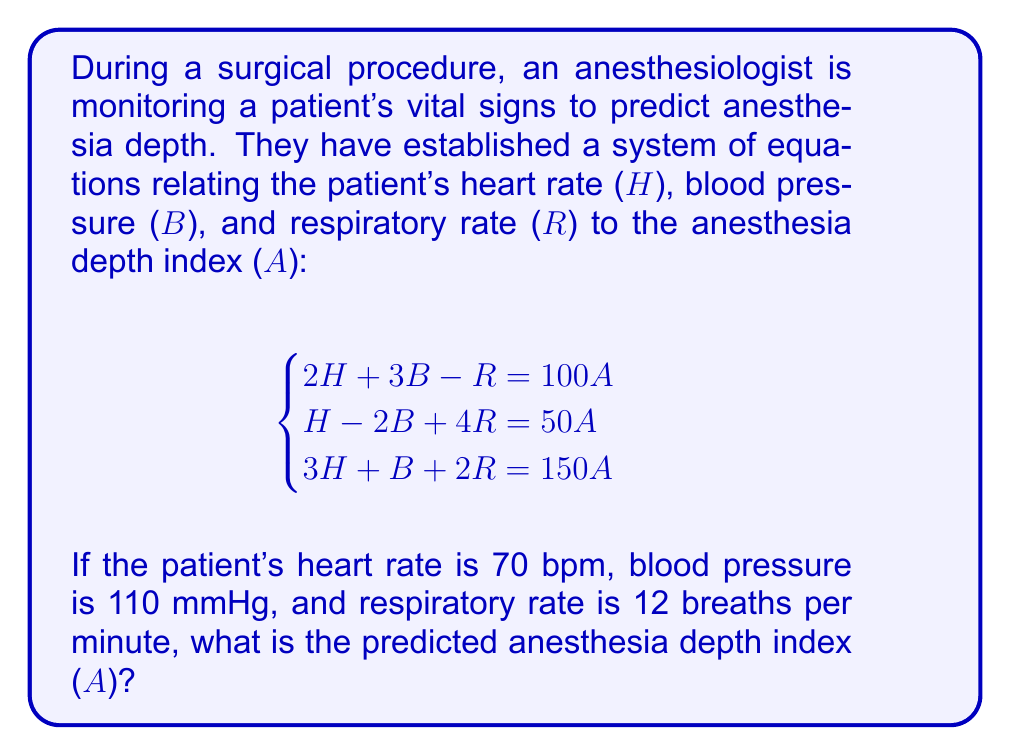Help me with this question. To solve this system of equations, we'll use the substitution method:

1) First, let's substitute the given values into our system of equations:
   $$\begin{cases}
   2(70) + 3(110) - 12 = 100A \\
   70 - 2(110) + 4(12) = 50A \\
   3(70) + 110 + 2(12) = 150A
   \end{cases}$$

2) Simplify:
   $$\begin{cases}
   140 + 330 - 12 = 100A \\
   70 - 220 + 48 = 50A \\
   210 + 110 + 24 = 150A
   \end{cases}$$

3) Further simplify:
   $$\begin{cases}
   458 = 100A \\
   -102 = 50A \\
   344 = 150A
   \end{cases}$$

4) Divide each equation by its coefficient of A:
   $$\begin{cases}
   4.58 = A \\
   -2.04 = A \\
   2.29 = A
   \end{cases}$$

5) We now have three different values for A. In a perfect system, these would all be equal. However, due to the complexity of biological systems and potential measurement errors, we often see slight variations. In this case, we'll take the average of these values to get our final answer:

   $$A = \frac{4.58 + (-2.04) + 2.29}{3} = \frac{4.83}{3} = 1.61$$

Therefore, the predicted anesthesia depth index is approximately 1.61.
Answer: $A \approx 1.61$ 